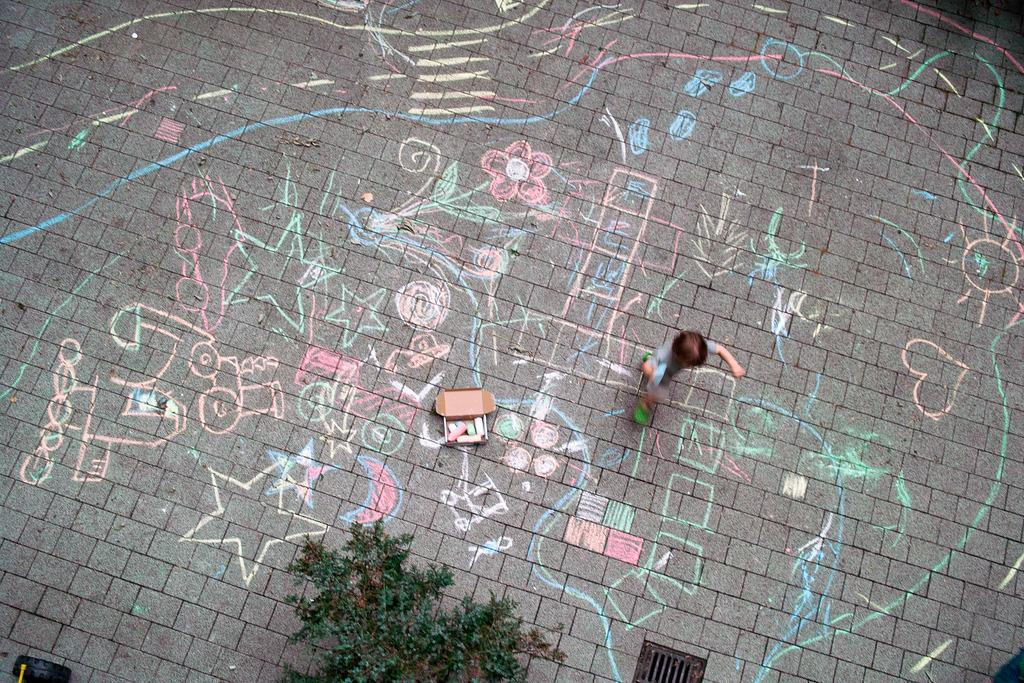Who is present in the image? There is a boy in the image. What is the boy doing in the image? The boy is creating a drawing on a surface with chocolate pieces. What other objects can be seen in the image? There is a tire, a plant, and a manhole in the image. What type of tank is visible in the image? There is no tank present in the image. What achievements has the boy accomplished in the image? The image does not provide information about the boy's achievements. 